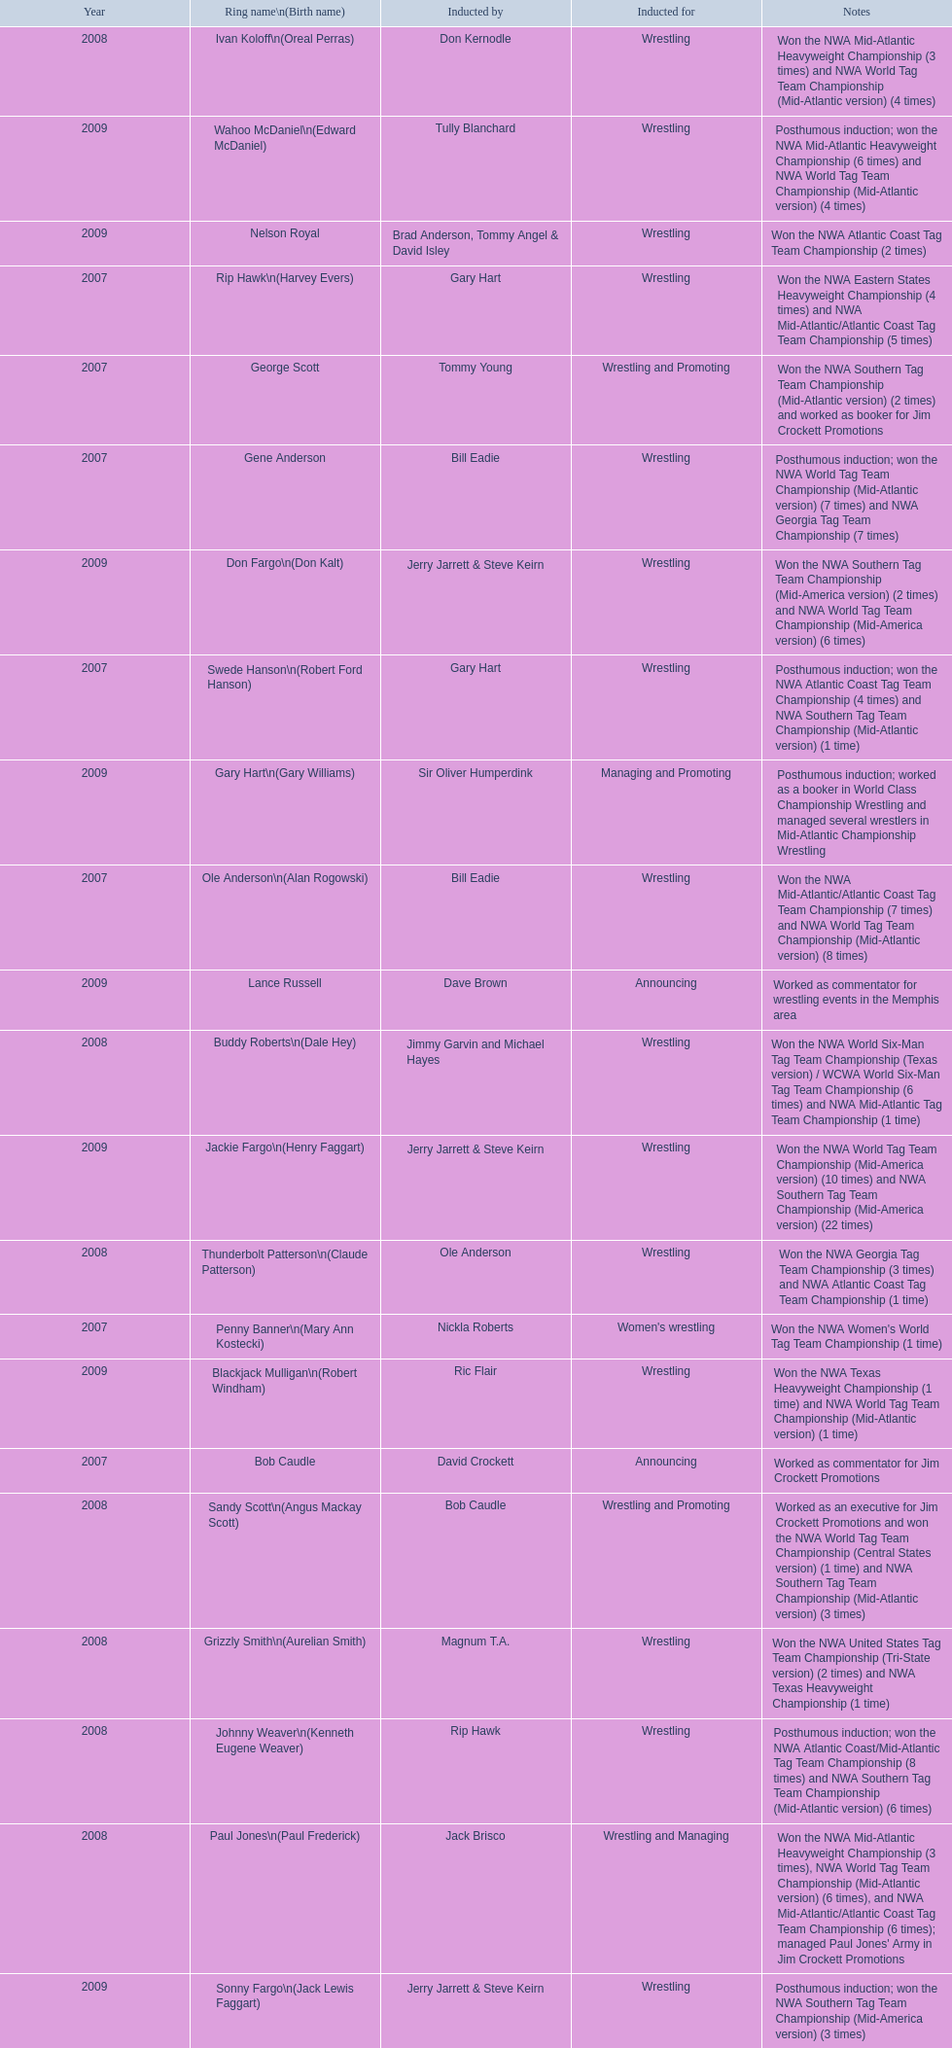What were all the wrestler's ring names? Gene Anderson, Ole Anderson\n(Alan Rogowski), Penny Banner\n(Mary Ann Kostecki), Bob Caudle, Swede Hanson\n(Robert Ford Hanson), Rip Hawk\n(Harvey Evers), George Scott, Paul Jones\n(Paul Frederick), Ivan Koloff\n(Oreal Perras), Thunderbolt Patterson\n(Claude Patterson), Buddy Roberts\n(Dale Hey), Sandy Scott\n(Angus Mackay Scott), Grizzly Smith\n(Aurelian Smith), Johnny Weaver\n(Kenneth Eugene Weaver), Don Fargo\n(Don Kalt), Jackie Fargo\n(Henry Faggart), Sonny Fargo\n(Jack Lewis Faggart), Gary Hart\n(Gary Williams), Wahoo McDaniel\n(Edward McDaniel), Blackjack Mulligan\n(Robert Windham), Nelson Royal, Lance Russell. Besides bob caudle, who was an announcer? Lance Russell. 